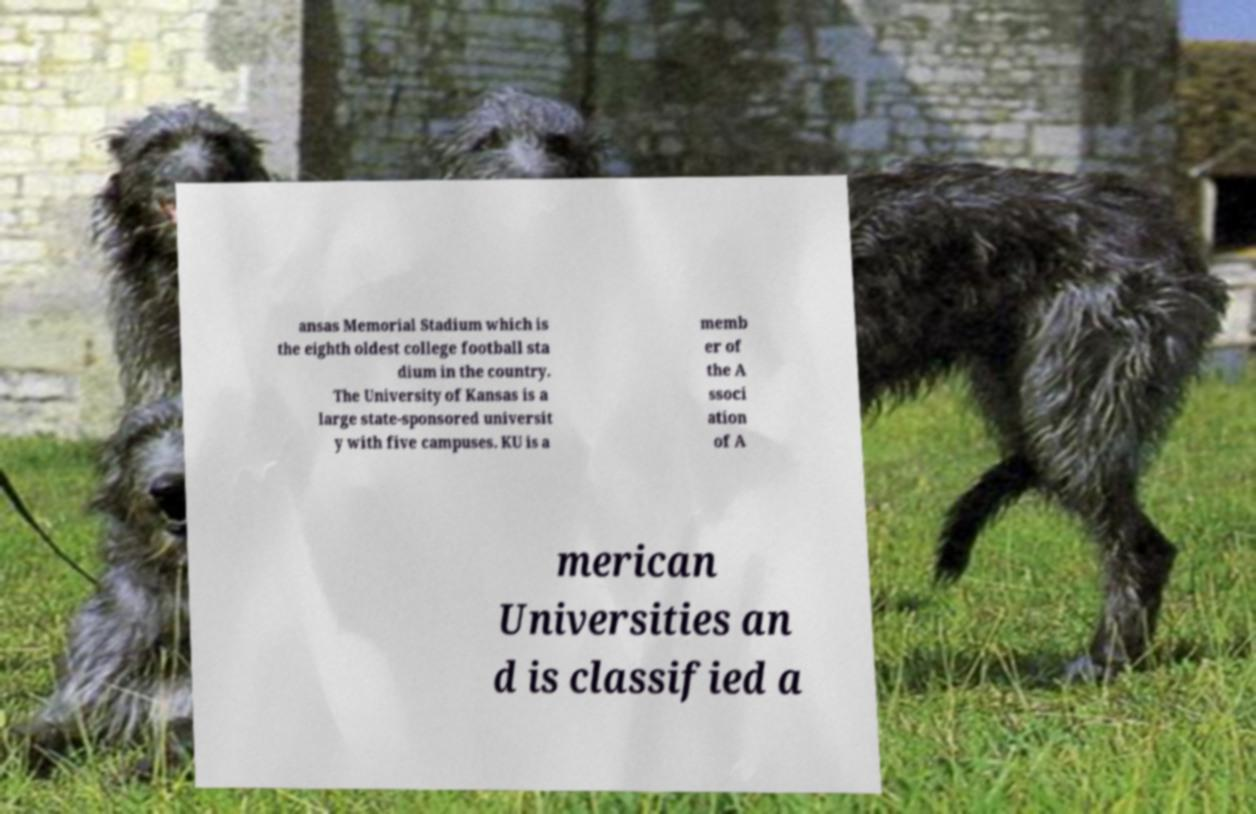Can you accurately transcribe the text from the provided image for me? ansas Memorial Stadium which is the eighth oldest college football sta dium in the country. The University of Kansas is a large state-sponsored universit y with five campuses. KU is a memb er of the A ssoci ation of A merican Universities an d is classified a 